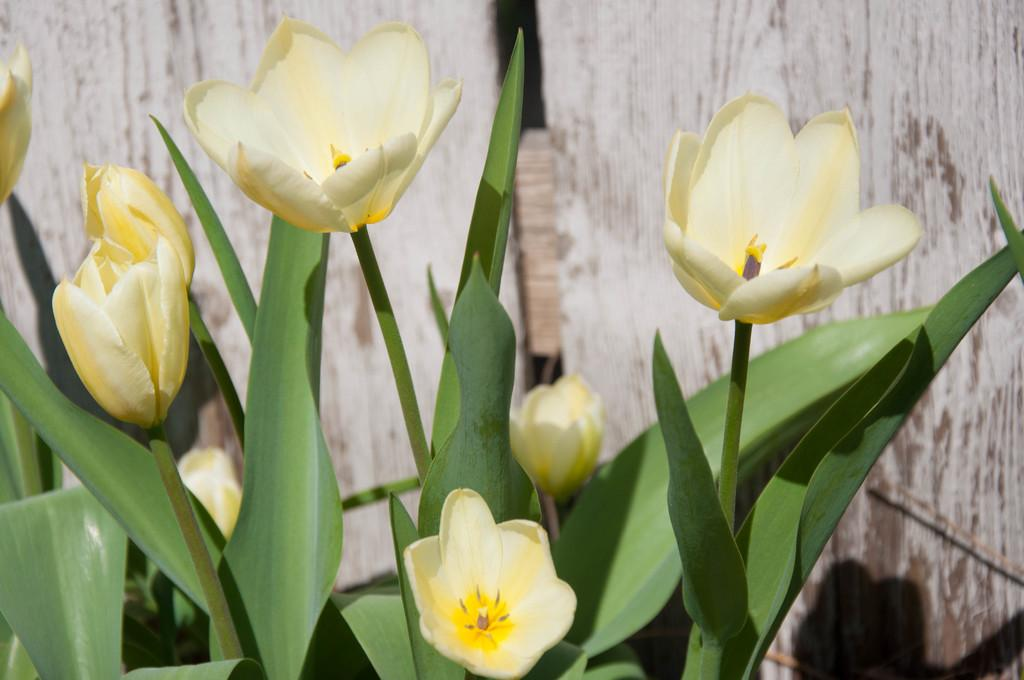What types of plants can be seen in the foreground of the image? There are flowers and plants in the foreground of the image. Can you describe the background of the image? There is a wall in the background of the image. What time of day is it at the seashore in the image? There is no seashore present in the image, and therefore no time of day can be determined for it. 